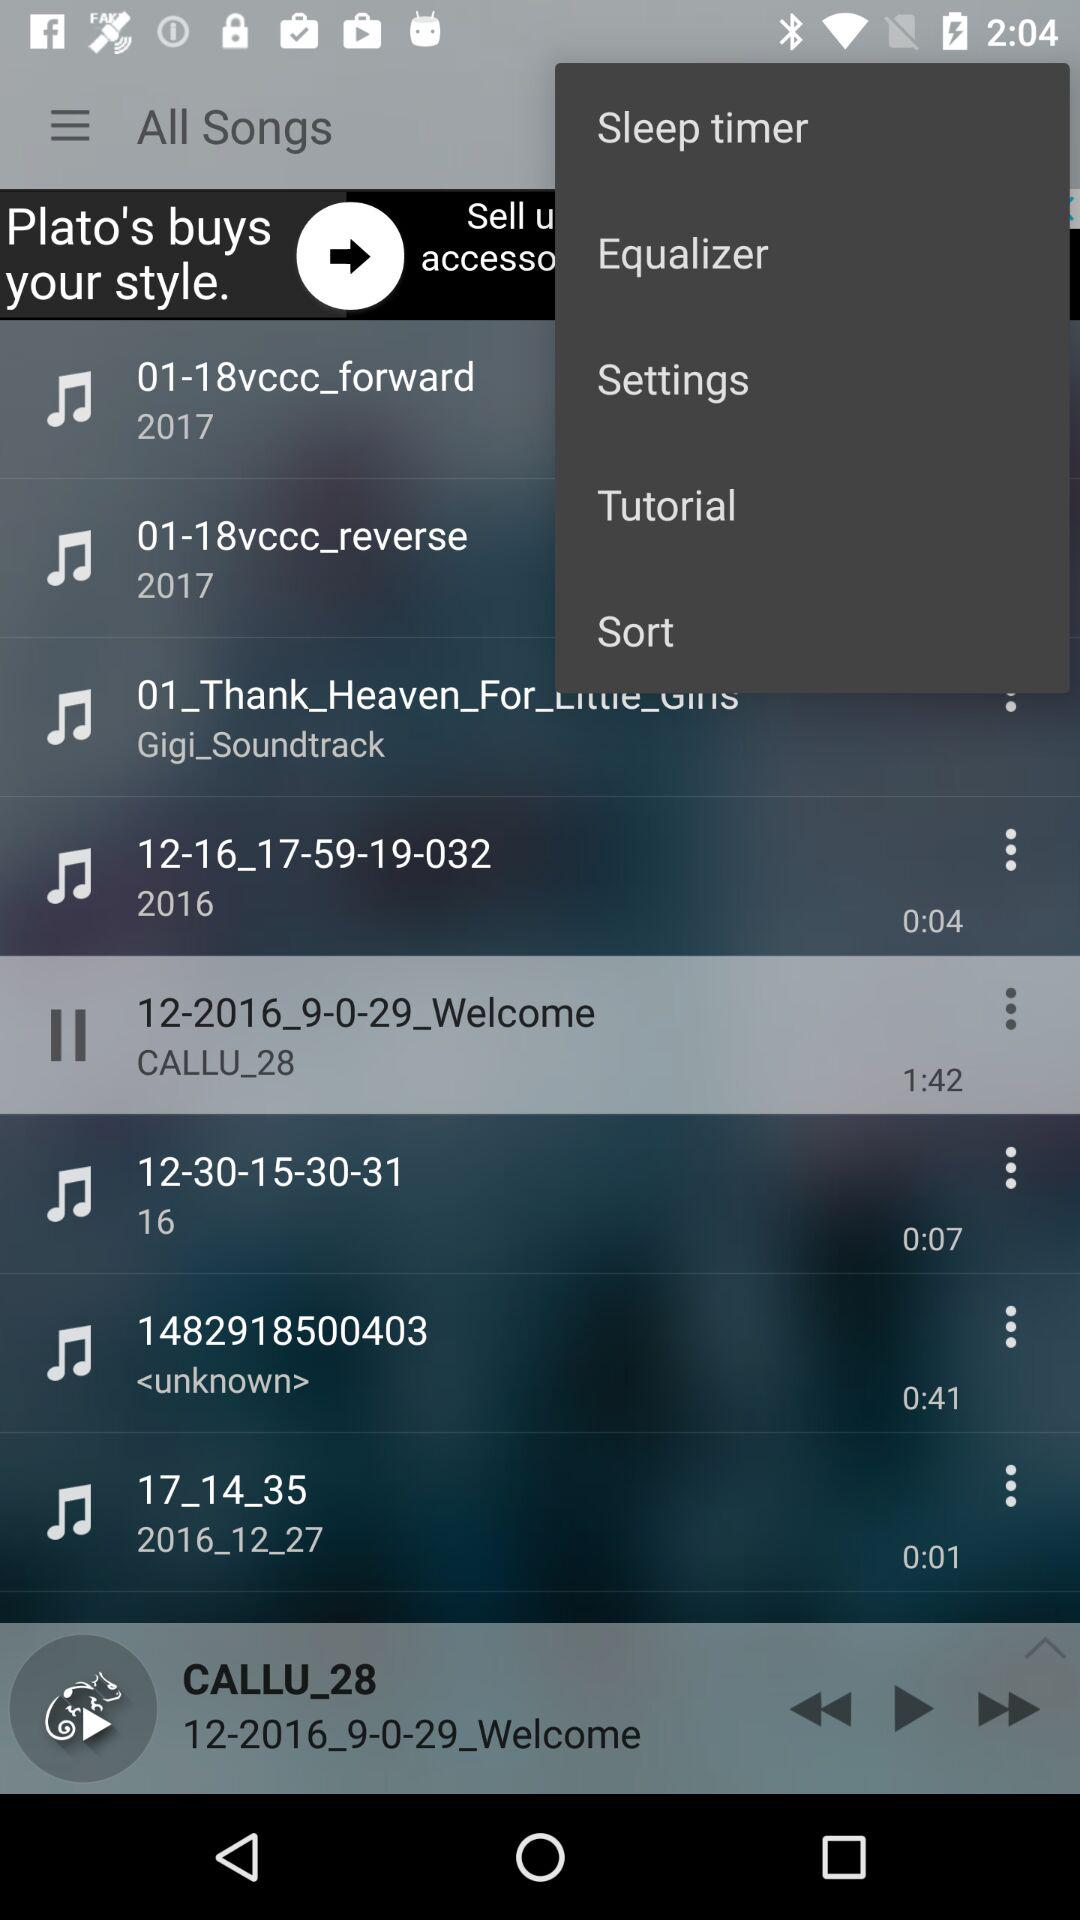What is the time duration of the "12-30-15-30-31" song? The time duration is 0:07. 